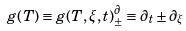Convert formula to latex. <formula><loc_0><loc_0><loc_500><loc_500>g ( T ) \equiv g ( T , \xi , t ) ^ { \partial } _ { \pm } \equiv \partial _ { t } \pm \partial _ { \xi }</formula> 